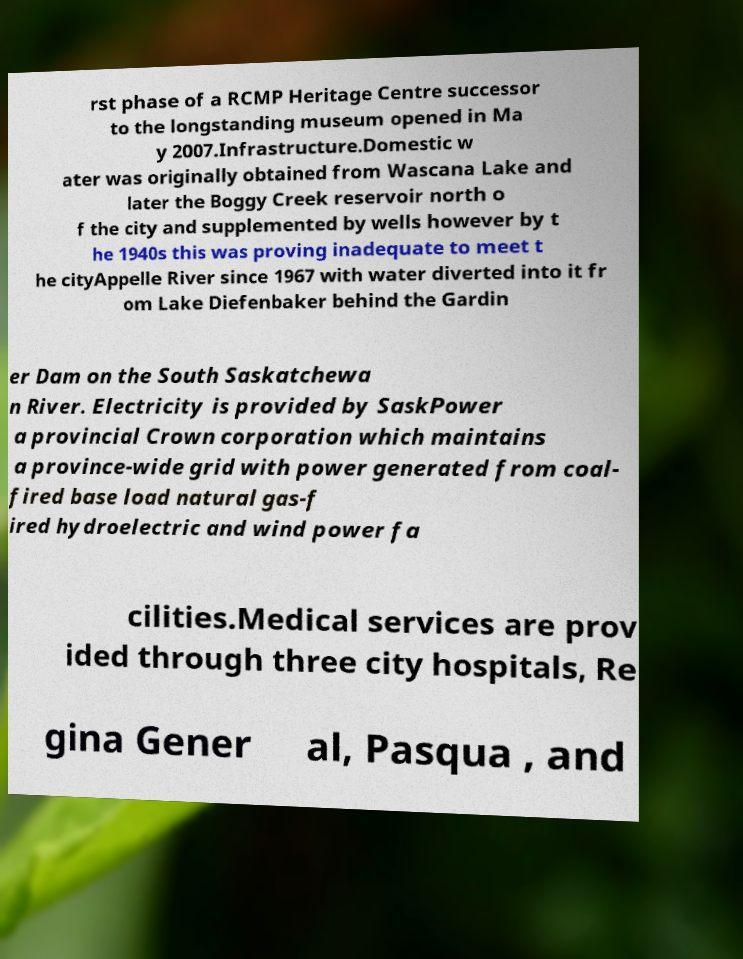Can you read and provide the text displayed in the image?This photo seems to have some interesting text. Can you extract and type it out for me? rst phase of a RCMP Heritage Centre successor to the longstanding museum opened in Ma y 2007.Infrastructure.Domestic w ater was originally obtained from Wascana Lake and later the Boggy Creek reservoir north o f the city and supplemented by wells however by t he 1940s this was proving inadequate to meet t he cityAppelle River since 1967 with water diverted into it fr om Lake Diefenbaker behind the Gardin er Dam on the South Saskatchewa n River. Electricity is provided by SaskPower a provincial Crown corporation which maintains a province-wide grid with power generated from coal- fired base load natural gas-f ired hydroelectric and wind power fa cilities.Medical services are prov ided through three city hospitals, Re gina Gener al, Pasqua , and 